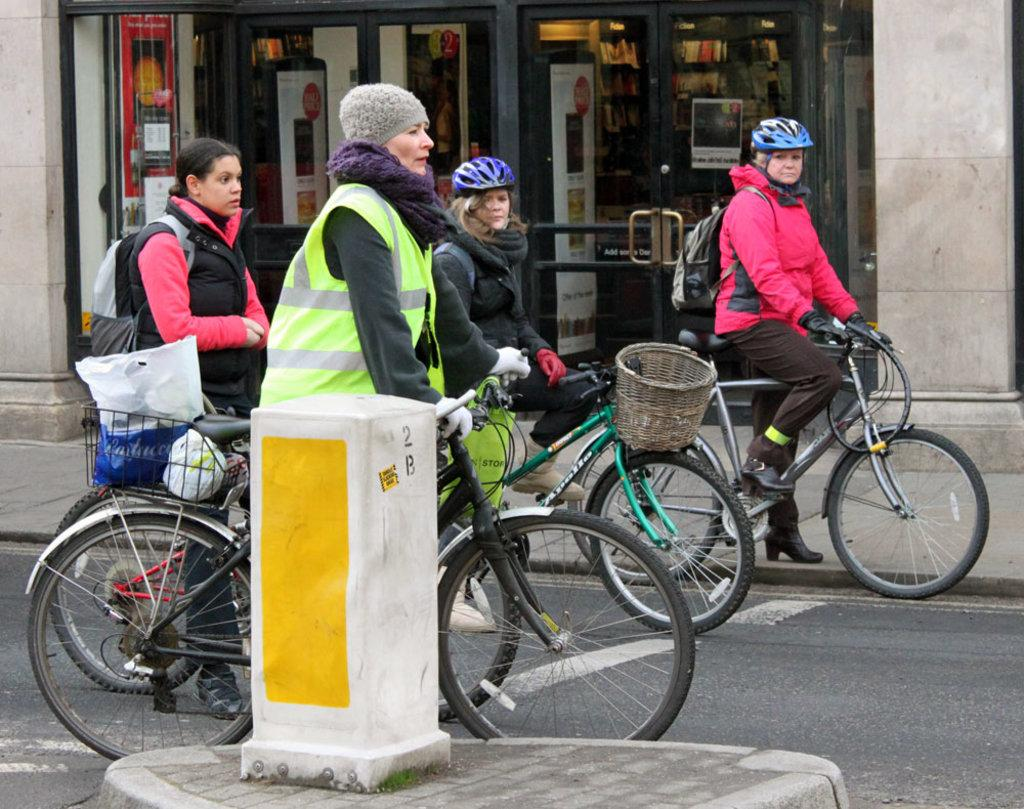Who is the main subject in the image? There is a woman in the image. What is the woman doing in the image? The woman is standing on a bicycle. Where is the bicycle located? The bicycle is on the road. What can be seen in the background of the image? There is a store in the background of the image. What is the woman carrying in the image? The woman is carrying a bag. What else is the woman wearing in the image? The woman is wearing a backpack. What type of ring is the woman wearing on her finger in the image? There is no ring visible on the woman's finger in the image. Who is the manager of the store in the background of the image? The image does not provide information about the store's manager. 